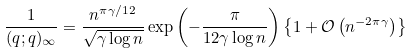Convert formula to latex. <formula><loc_0><loc_0><loc_500><loc_500>\frac { 1 } { ( q ; q ) _ { \infty } } = \frac { n ^ { \pi \gamma / 1 2 } } { \sqrt { \gamma \log n } } \exp \left ( - \frac { \pi } { 1 2 \gamma \log n } \right ) \left \{ 1 + \mathcal { O } \left ( n ^ { - 2 \pi \gamma } \right ) \right \}</formula> 